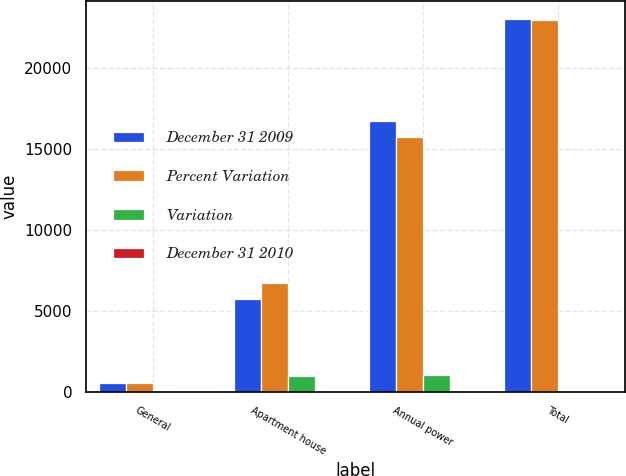Convert chart to OTSL. <chart><loc_0><loc_0><loc_500><loc_500><stacked_bar_chart><ecel><fcel>General<fcel>Apartment house<fcel>Annual power<fcel>Total<nl><fcel>December 31 2009<fcel>515<fcel>5748<fcel>16767<fcel>23030<nl><fcel>Percent Variation<fcel>544<fcel>6725<fcel>15748<fcel>23017<nl><fcel>Variation<fcel>29<fcel>977<fcel>1019<fcel>13<nl><fcel>December 31 2010<fcel>5.3<fcel>14.5<fcel>6.5<fcel>0.1<nl></chart> 